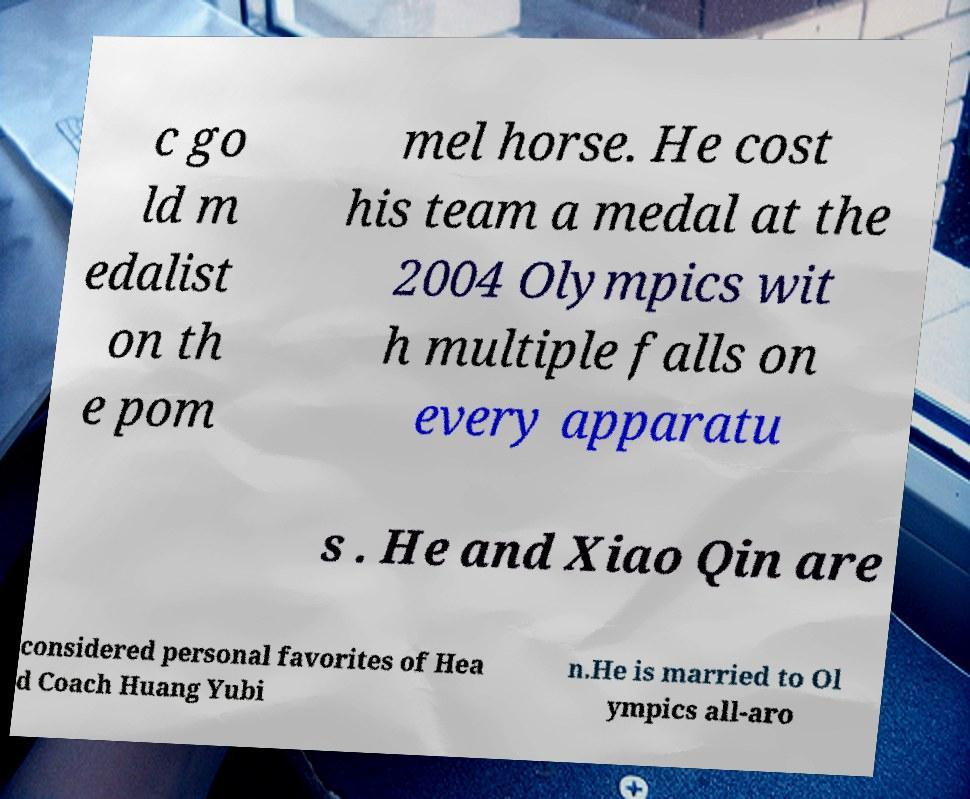For documentation purposes, I need the text within this image transcribed. Could you provide that? c go ld m edalist on th e pom mel horse. He cost his team a medal at the 2004 Olympics wit h multiple falls on every apparatu s . He and Xiao Qin are considered personal favorites of Hea d Coach Huang Yubi n.He is married to Ol ympics all-aro 